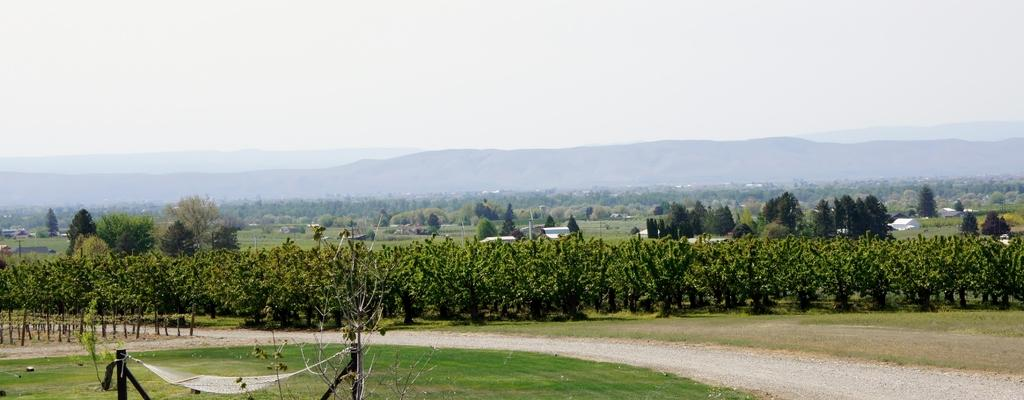What type of vegetation can be seen in the image? There are trees in the image. What type of structures are present in the image? There are buildings in the image. What type of terrain is visible in the image? There are hills in the image. What is the condition of the sky in the image? The sky is cloudy in the image. What type of objects are visible in the image that might be used for support or signage? There are poles visible in the image. What type of ground cover is present in the image? Grass is present on the ground in the image. How many cakes are being swung by the trees in the image? There are no cakes or swings present in the image; it features trees, buildings, hills, a cloudy sky, poles, and grass. 